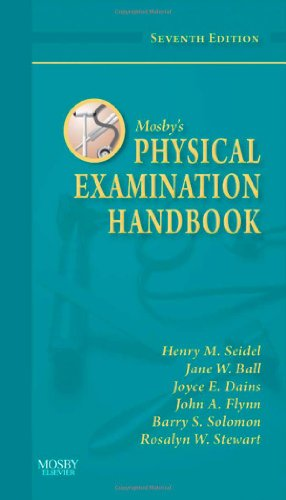What updates might be found in this seventh edition compared to earlier versions? The seventh edition likely includes updated medical practices, enhanced visual elements such as diagrams and illustrations, and possibly new sections on contemporary health issues. 